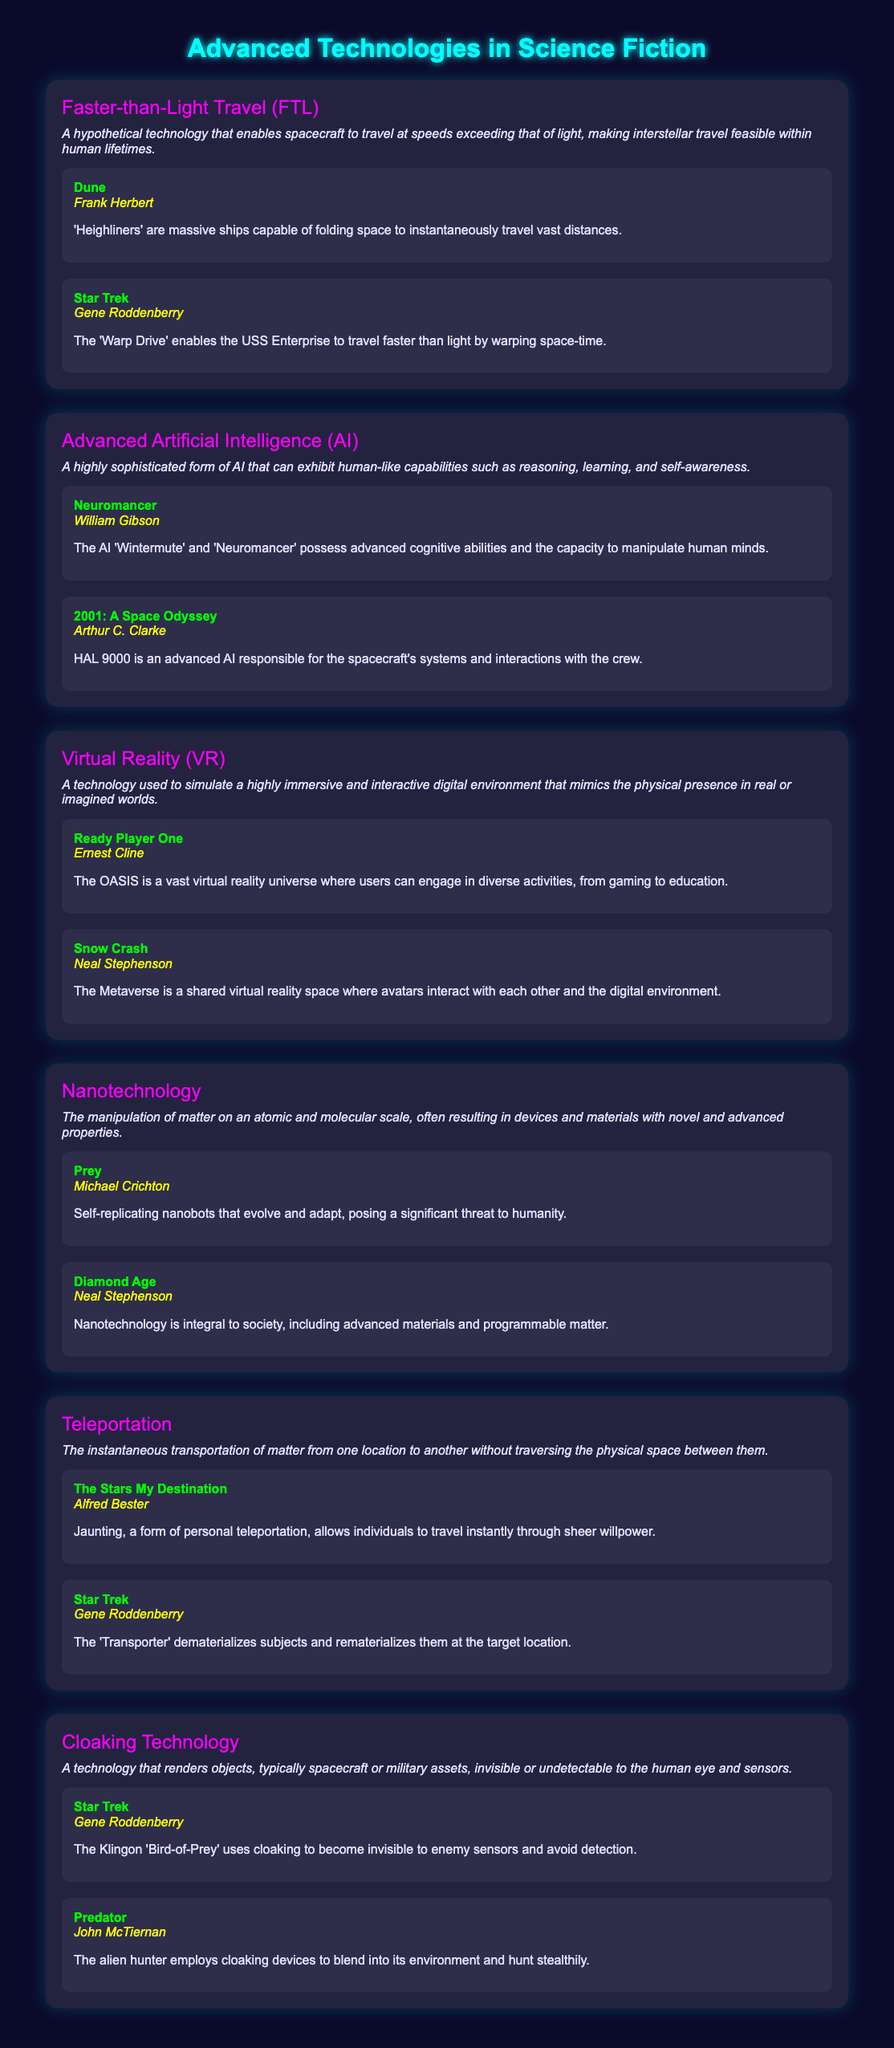What is Faster-than-Light Travel (FTL)? FTL is a hypothetical technology that enables spacecraft to travel at speeds exceeding that of light.
Answer: Hypothetical technology Who authored 'Neuromancer'? 'Neuromancer' is a notable work by William Gibson, mentioned under Advanced AI.
Answer: William Gibson What does HAL 9000 represent? HAL 9000 is an advanced AI responsible for the spacecraft's systems and interactions with the crew in '2001: A Space Odyssey'.
Answer: Advanced AI Which novel features the concept of teleportation called Jaunting? In 'The Stars My Destination,' Jaunting is a form of personal teleportation that allows instant travel.
Answer: The Stars My Destination What technology is used in the Klingon 'Bird-of-Prey'? The Klingon 'Bird-of-Prey' uses cloaking technology to become invisible to sensors.
Answer: Cloaking technology Name one example of Advanced Artificial Intelligence mentioned. 'Neuromancer' features the AI 'Wintermute,' which exhibits advanced cognitive abilities.
Answer: Wintermute How is faster-than-light travel achieved in 'Dune'? In 'Dune,' Heighliners are massive ships capable of folding space to instantaneously travel.
Answer: Folding space What immersive technology is used in 'Ready Player One'? In 'Ready Player One,' the OASIS is a vast virtual reality universe.
Answer: Virtual Reality Who is the author of 'The Diamond Age'? 'The Diamond Age' is authored by Neal Stephenson.
Answer: Neal Stephenson What are self-replicating nanobots depicted in? Self-replicating nanobots are depicted in 'Prey' by Michael Crichton.
Answer: Prey 